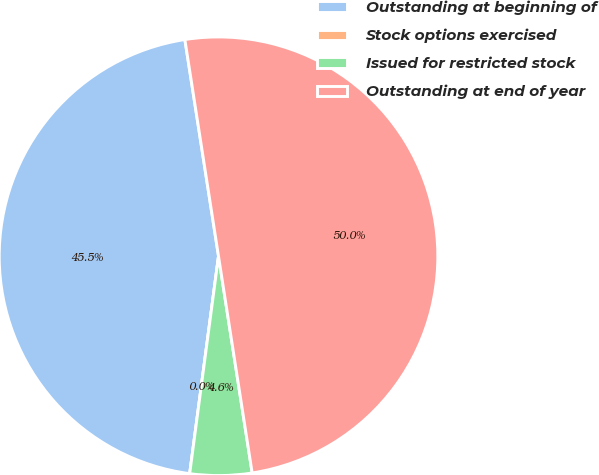<chart> <loc_0><loc_0><loc_500><loc_500><pie_chart><fcel>Outstanding at beginning of<fcel>Stock options exercised<fcel>Issued for restricted stock<fcel>Outstanding at end of year<nl><fcel>45.45%<fcel>0.0%<fcel>4.55%<fcel>50.0%<nl></chart> 